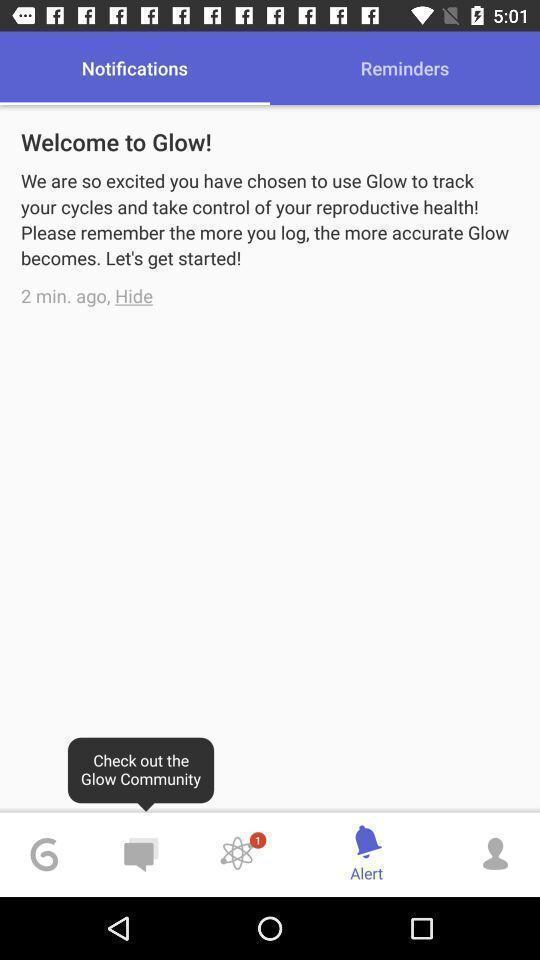What details can you identify in this image? Welcome page. 